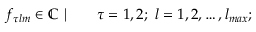Convert formula to latex. <formula><loc_0><loc_0><loc_500><loc_500>\begin{array} { r l } { f _ { \tau l m } \in \mathbb { C } \ | \quad } & \tau = 1 , 2 ; \ l = 1 , 2 , \dots , l _ { \max } ; } \end{array}</formula> 